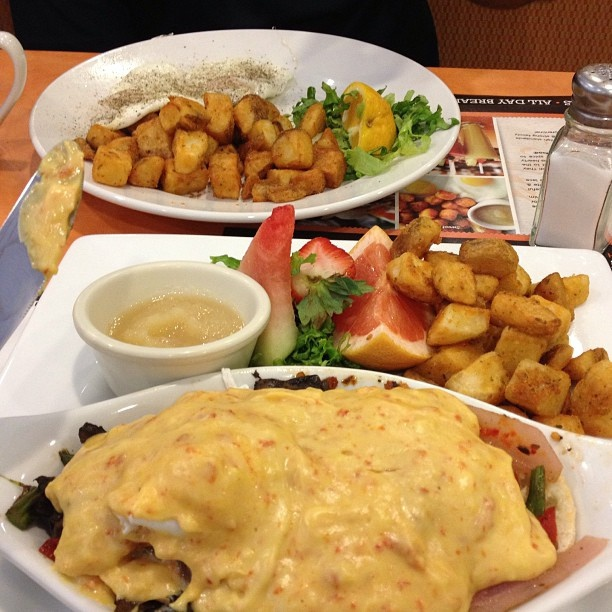Describe the objects in this image and their specific colors. I can see bowl in maroon, brown, lightgray, and tan tones, bowl in maroon and tan tones, bottle in maroon, darkgray, tan, and gray tones, knife in maroon, tan, and gray tones, and dining table in maroon, red, and salmon tones in this image. 